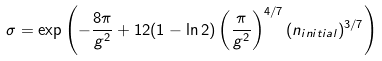<formula> <loc_0><loc_0><loc_500><loc_500>\sigma = \exp \left ( - \frac { 8 \pi } { g ^ { 2 } } + 1 2 ( 1 - \ln 2 ) \left ( \frac { \pi } { g ^ { 2 } } \right ) ^ { 4 / 7 } ( n _ { i n i t i a l } ) ^ { 3 / 7 } \right )</formula> 